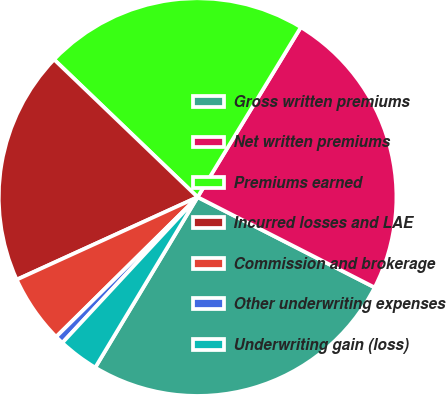Convert chart to OTSL. <chart><loc_0><loc_0><loc_500><loc_500><pie_chart><fcel>Gross written premiums<fcel>Net written premiums<fcel>Premiums earned<fcel>Incurred losses and LAE<fcel>Commission and brokerage<fcel>Other underwriting expenses<fcel>Underwriting gain (loss)<nl><fcel>26.1%<fcel>23.82%<fcel>21.53%<fcel>18.98%<fcel>5.59%<fcel>0.69%<fcel>3.3%<nl></chart> 